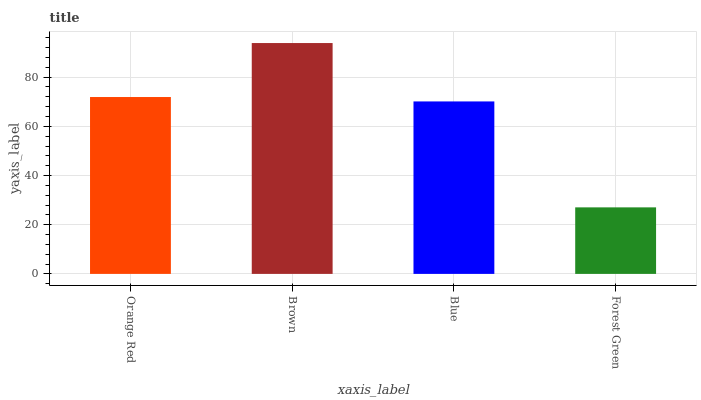Is Forest Green the minimum?
Answer yes or no. Yes. Is Brown the maximum?
Answer yes or no. Yes. Is Blue the minimum?
Answer yes or no. No. Is Blue the maximum?
Answer yes or no. No. Is Brown greater than Blue?
Answer yes or no. Yes. Is Blue less than Brown?
Answer yes or no. Yes. Is Blue greater than Brown?
Answer yes or no. No. Is Brown less than Blue?
Answer yes or no. No. Is Orange Red the high median?
Answer yes or no. Yes. Is Blue the low median?
Answer yes or no. Yes. Is Brown the high median?
Answer yes or no. No. Is Orange Red the low median?
Answer yes or no. No. 